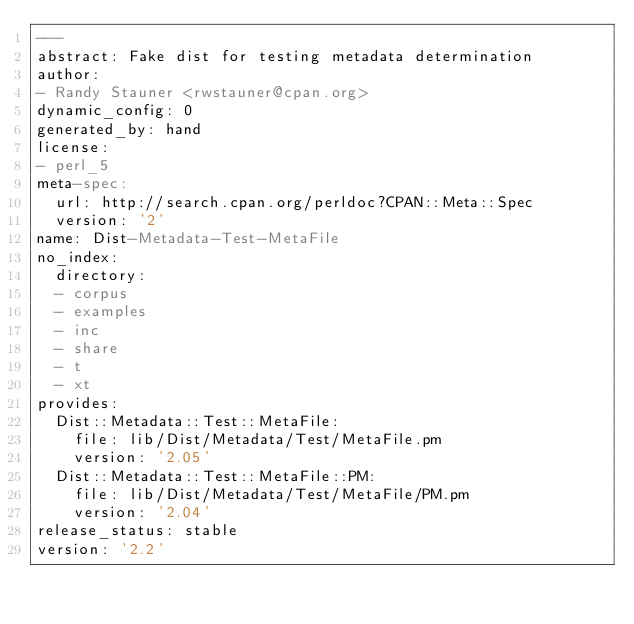<code> <loc_0><loc_0><loc_500><loc_500><_YAML_>---
abstract: Fake dist for testing metadata determination
author:
- Randy Stauner <rwstauner@cpan.org>
dynamic_config: 0
generated_by: hand
license:
- perl_5
meta-spec:
  url: http://search.cpan.org/perldoc?CPAN::Meta::Spec
  version: '2'
name: Dist-Metadata-Test-MetaFile
no_index:
  directory:
  - corpus
  - examples
  - inc
  - share
  - t
  - xt
provides:
  Dist::Metadata::Test::MetaFile:
    file: lib/Dist/Metadata/Test/MetaFile.pm
    version: '2.05'
  Dist::Metadata::Test::MetaFile::PM:
    file: lib/Dist/Metadata/Test/MetaFile/PM.pm
    version: '2.04'
release_status: stable
version: '2.2'
</code> 